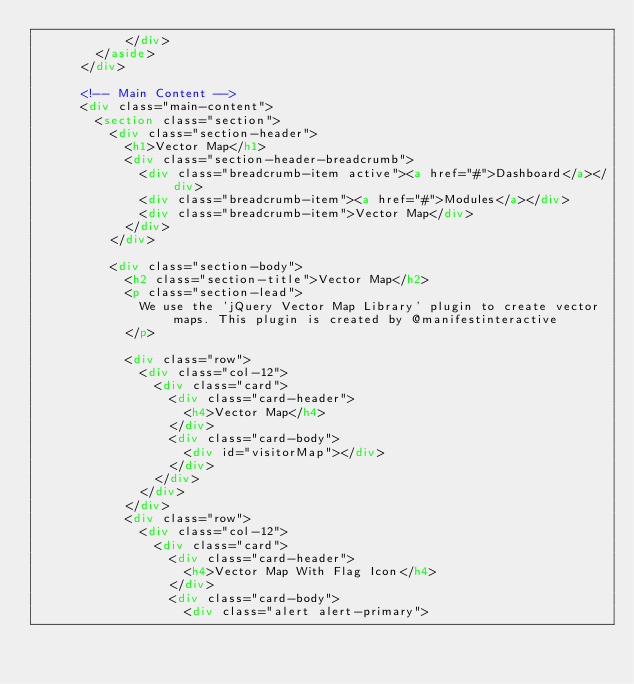Convert code to text. <code><loc_0><loc_0><loc_500><loc_500><_HTML_>            </div>
        </aside>
      </div>

      <!-- Main Content -->
      <div class="main-content">
        <section class="section">
          <div class="section-header">
            <h1>Vector Map</h1>
            <div class="section-header-breadcrumb">
              <div class="breadcrumb-item active"><a href="#">Dashboard</a></div>
              <div class="breadcrumb-item"><a href="#">Modules</a></div>
              <div class="breadcrumb-item">Vector Map</div>
            </div>
          </div>

          <div class="section-body">
            <h2 class="section-title">Vector Map</h2>
            <p class="section-lead">
              We use the 'jQuery Vector Map Library' plugin to create vector maps. This plugin is created by @manifestinteractive
            </p>

            <div class="row">
              <div class="col-12">
                <div class="card">
                  <div class="card-header">
                    <h4>Vector Map</h4>
                  </div>
                  <div class="card-body">
                    <div id="visitorMap"></div>
                  </div>
                </div>
              </div>
            </div>
            <div class="row">
              <div class="col-12">
                <div class="card">
                  <div class="card-header">
                    <h4>Vector Map With Flag Icon</h4>
                  </div>
                  <div class="card-body">
                    <div class="alert alert-primary"></code> 